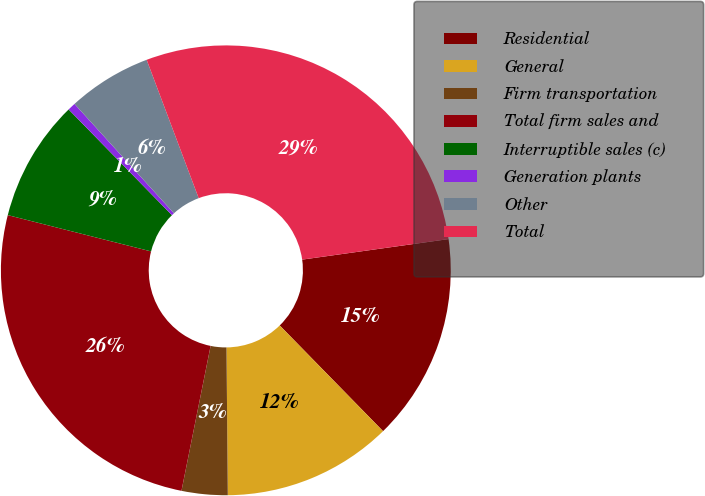Convert chart to OTSL. <chart><loc_0><loc_0><loc_500><loc_500><pie_chart><fcel>Residential<fcel>General<fcel>Firm transportation<fcel>Total firm sales and<fcel>Interruptible sales (c)<fcel>Generation plants<fcel>Other<fcel>Total<nl><fcel>14.9%<fcel>12.18%<fcel>3.3%<fcel>25.79%<fcel>8.74%<fcel>0.57%<fcel>6.02%<fcel>28.51%<nl></chart> 